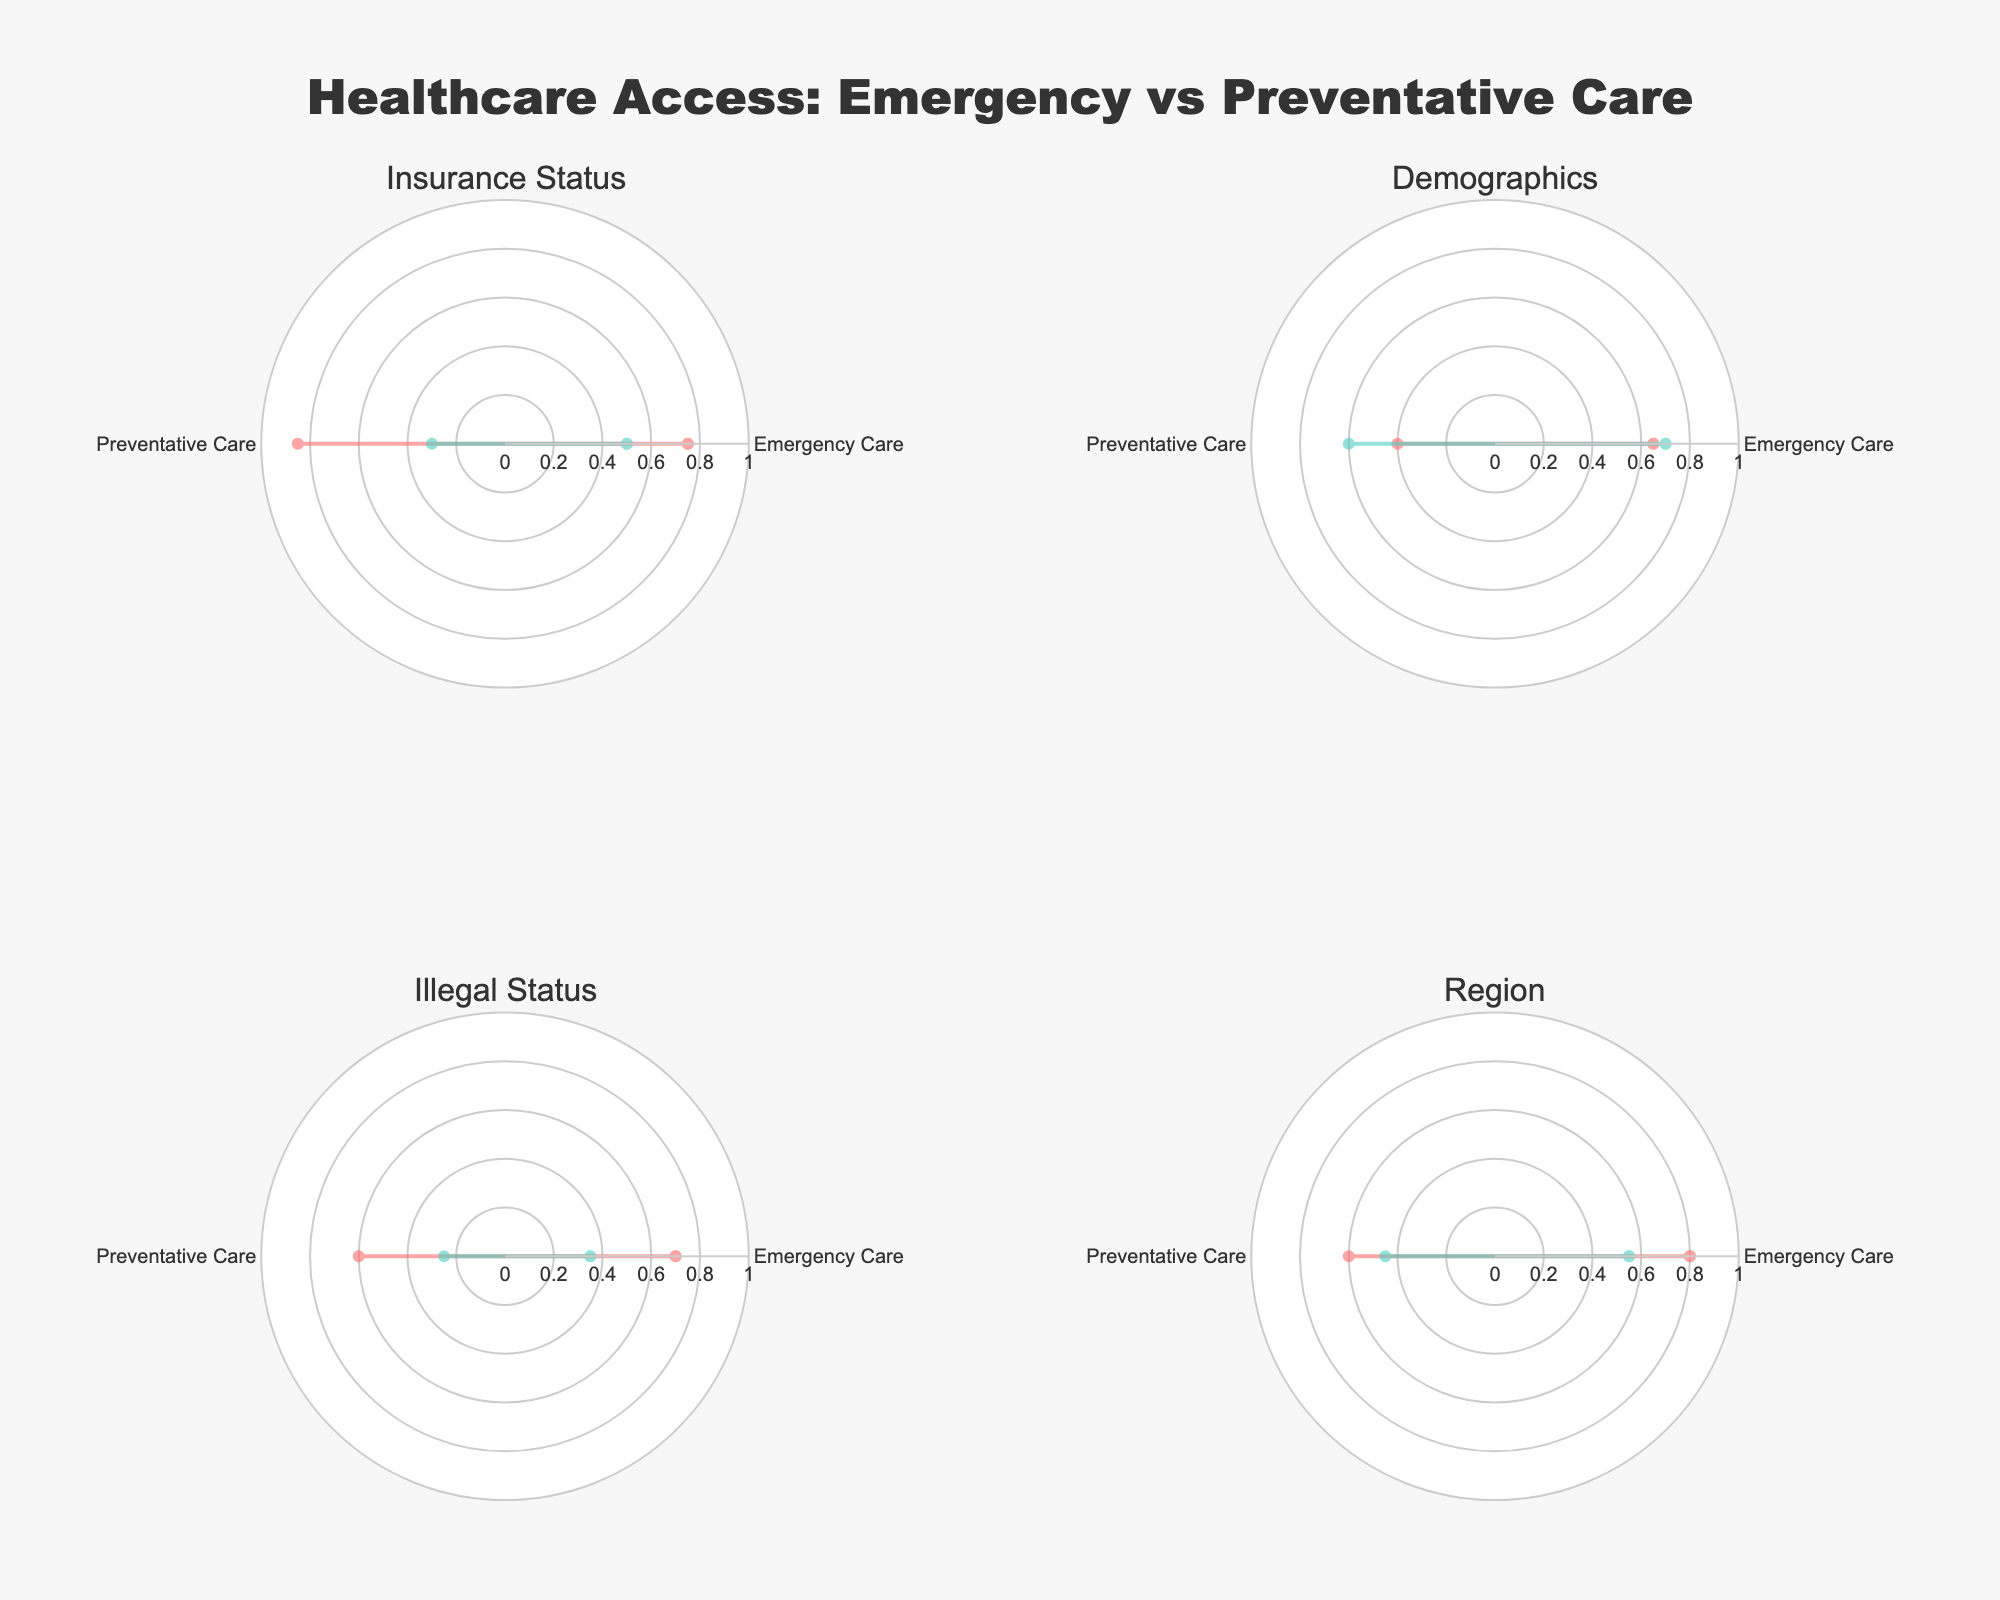What is the title of the figure? The title of the figure is usually placed prominently at the top of the plot. By looking at the figure, we can see the title text displayed there.
Answer: Healthcare Access: Emergency vs Preventative Care Which category has the highest emergency care access for insured entities? By examining the subplot related to "Insurance Status," we notice two data points for insured and uninsured entities. The insured entity shows an emergency care access value of 0.75.
Answer: Insurance Status What is the difference in preventative care access between teenagers and adults? Locate the "Demographics" subplot, then find the preventative care access values for teenagers (0.40) and adults (0.60). Subtract these values to get the difference.
Answer: 0.20 Do documented refugees have higher preventative care access compared to uninsured individuals? In the subplot for "Illegal Status," identify the preventative care access for documented refugees (0.60). In the "Insurance Status" subplot, find the preventative care access for uninsured individuals (0.30). Compare these values.
Answer: Yes Compare the emergency care access for urban and rural areas. Which one is higher? Check the "Region" subplot to find emergency care access values for urban (0.80) and rural areas (0.55). Note which value is higher.
Answer: Urban Area Which entity has the lowest values for both emergency and preventative care access in their respective category? By reviewing each subplot, look for the entity with the lowest values in both emergency and preventative care access. This entity appears in the "Illegal Status" category as "Undocumented Refugee" with 0.35 and 0.25, respectively.
Answer: Undocumented Refugee What are the emergency and preventative care access values for adults in the demographics category? Check the "Demographics" subplot and identify the data points for adults. The values listed are 0.70 for emergency care access and 0.60 for preventative care access.
Answer: Emergency Care: 0.70, Preventative Care: 0.60 Which entity has an equal value for emergency and preventative care access? Examine the data points in each subplot to find any entity with equal values for both types of care access. None of the entities exhibit equal values.
Answer: None Based on the figure, which category shows a greater disparity between entities in preventative care access, Insurance Status or Illegal Status? Compare the differences in preventative care access between entities in the "Insurance Status" (0.55 difference: 0.85 for insured, 0.30 for uninsured) and "Illegal Status" (0.35 difference: 0.60 for documented, 0.25 for undocumented).
Answer: Insurance Status In the "Region" category, how much higher is emergency care access in urban areas compared to rural areas? Locate the emergency care access values in the "Region" subplot; urban areas have a value of 0.80, and rural areas have 0.55. Calculate the difference (0.80 - 0.55).
Answer: 0.25 